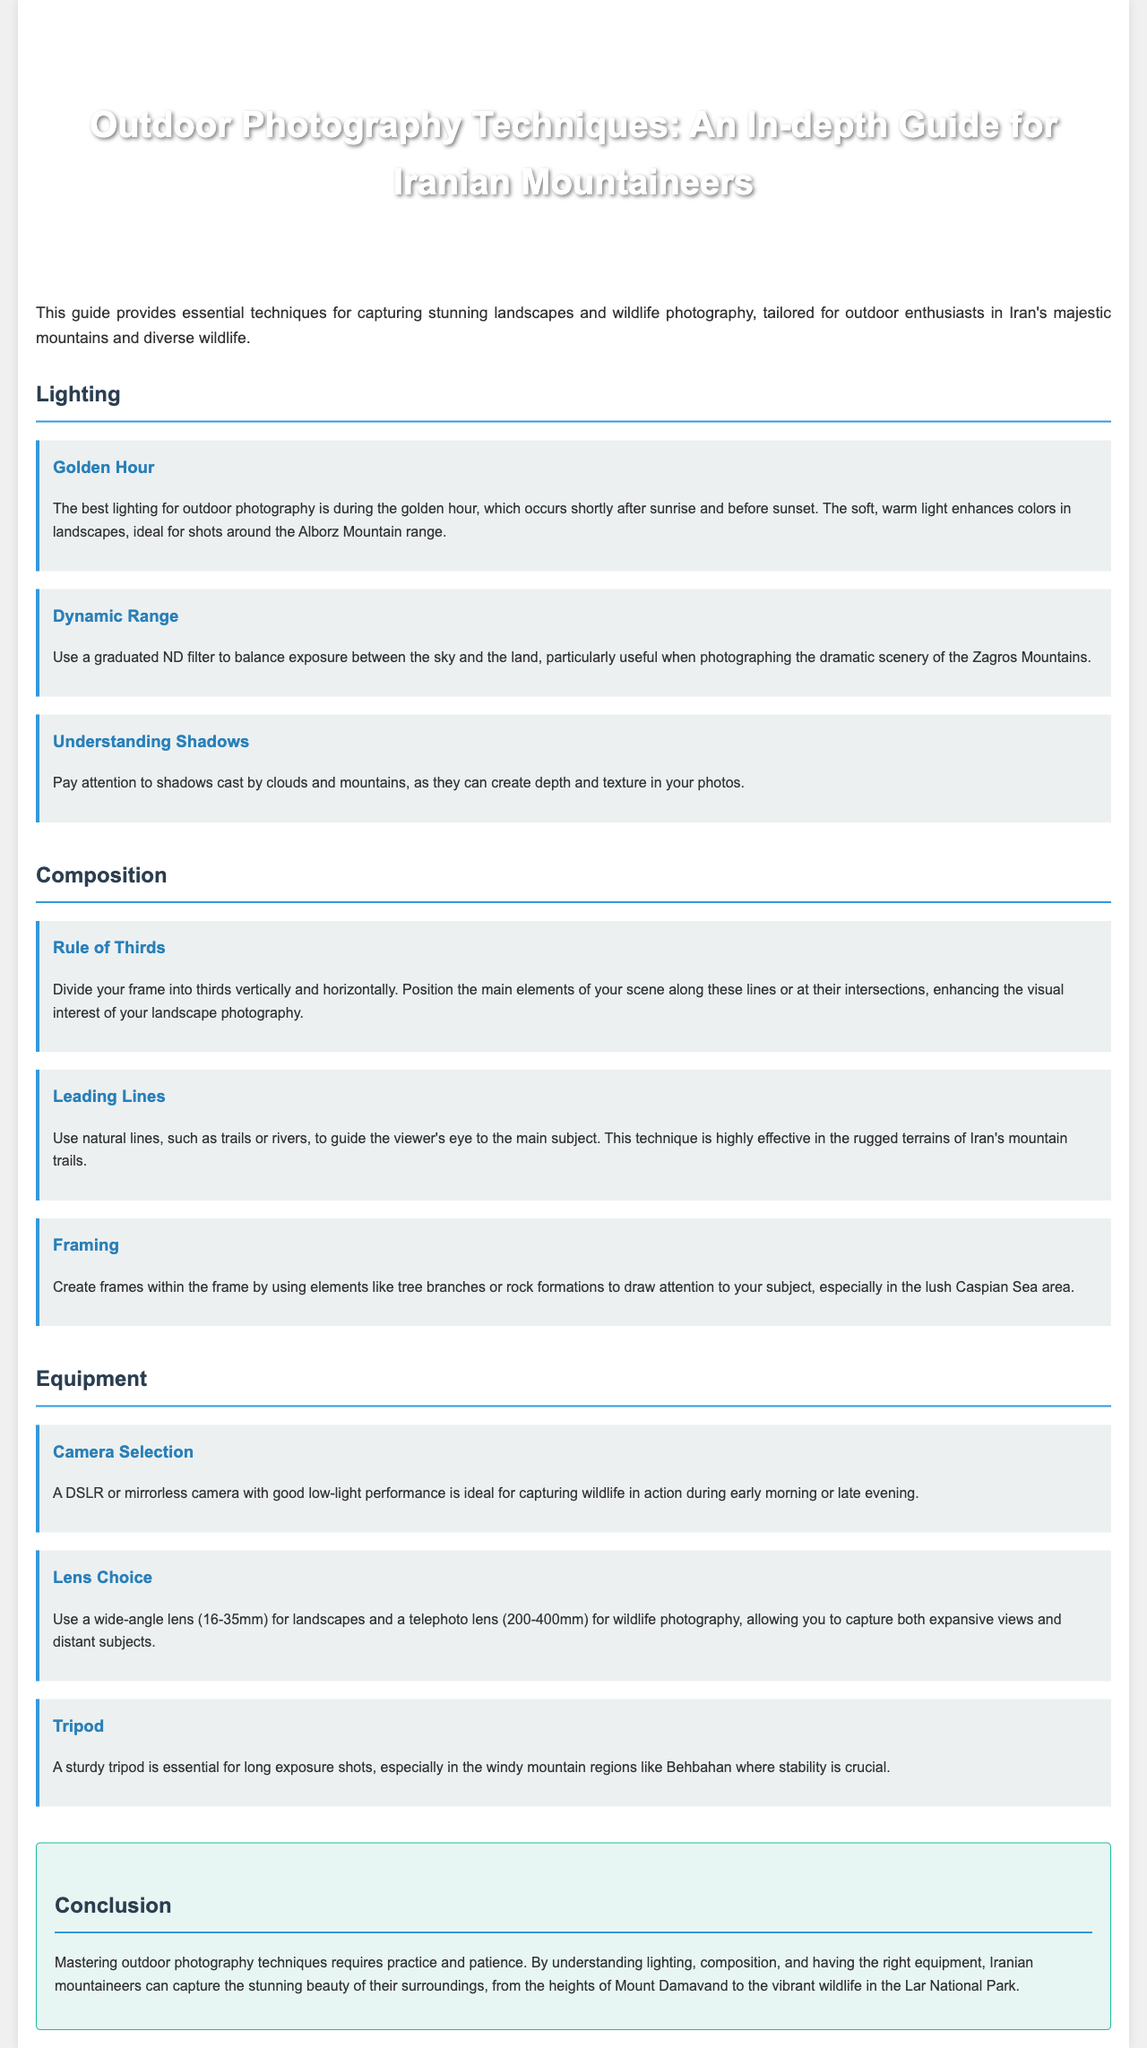what is the title of the document? The title of the document is stated in the header of the HTML, which is about outdoor photography techniques for Iranian mountaineers.
Answer: Outdoor Photography Techniques: An In-depth Guide for Iranian Mountaineers what is the best time for taking photos outdoors? The document mentions that the best lighting for outdoor photography is referred to as golden hour, which occurs shortly after sunrise and before sunset.
Answer: Golden Hour which mountain range is specifically mentioned for photography tips? The document includes the Alborz Mountain range as notable for enhancing colors with the soft, warm light during the golden hour.
Answer: Alborz Mountain range what composition rule is advised in landscape photography? The document recommends dividing the frame into thirds both vertically and horizontally to position key elements effectively.
Answer: Rule of Thirds what equipment is essential for long exposure shots? The document states that a sturdy tripod is crucial for maintaining stability during long exposure photography in windy conditions.
Answer: Tripod which type of lens is suggested for wildlife photography? The guide recommends using a telephoto lens within the range of 200-400mm to effectively capture wildlife from a distance.
Answer: Telephoto lens (200-400mm) what is a key factor to consider when photographing shadows? The document emphasizes paying attention to shadows cast by clouds and mountains to create depth and texture in photos.
Answer: Depth and texture what type of camera is ideal for capturing wildlife in action? A DSLR or mirrorless camera with good low-light performance is mentioned as the ideal choice for wildlife photography.
Answer: DSLR or mirrorless camera what area is highlighted for creating frames within the frame? The document suggests using elements like tree branches or rock formations to create frames specifically in the lush Caspian Sea area.
Answer: Caspian Sea area 